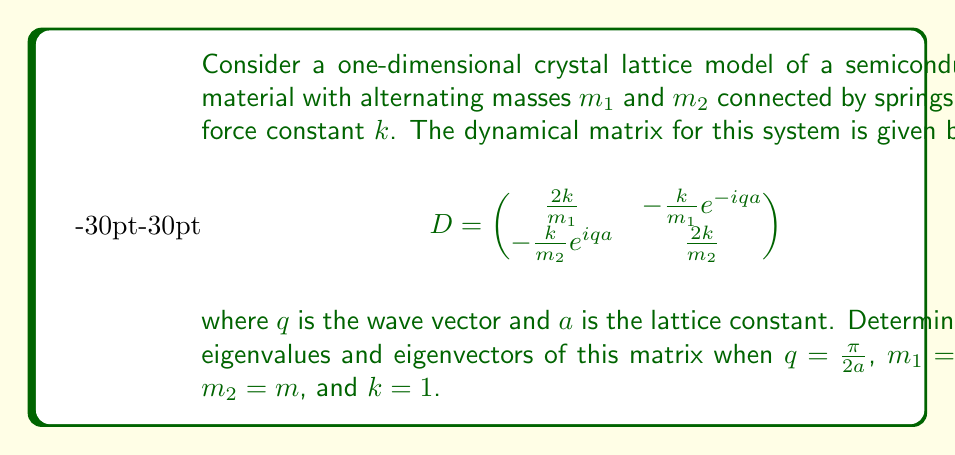Show me your answer to this math problem. To solve this problem, we'll follow these steps:

1) First, let's substitute the given values into the dynamical matrix:
   $q = \frac{\pi}{2a}$, $m_1 = 2m$, $m_2 = m$, and $k = 1$

   $$D = \begin{pmatrix}
   \frac{1}{m} & -\frac{1}{2m}e^{-i\frac{\pi}{2}} \\
   -\frac{1}{m}e^{i\frac{\pi}{2}} & \frac{2}{m}
   \end{pmatrix}$$

2) Simplify using $e^{-i\frac{\pi}{2}} = -i$ and $e^{i\frac{\pi}{2}} = i$:

   $$D = \begin{pmatrix}
   \frac{1}{m} & \frac{i}{2m} \\
   -\frac{i}{m} & \frac{2}{m}
   \end{pmatrix}$$

3) To find the eigenvalues, we solve the characteristic equation:
   $\det(D - \lambda I) = 0$

   $$\begin{vmatrix}
   \frac{1}{m} - \lambda & \frac{i}{2m} \\
   -\frac{i}{m} & \frac{2}{m} - \lambda
   \end{vmatrix} = 0$$

4) Expand the determinant:
   $(\frac{1}{m} - \lambda)(\frac{2}{m} - \lambda) + \frac{1}{2m^2} = 0$

5) Simplify:
   $\lambda^2 - \frac{3}{m}\lambda + \frac{1}{m^2} = 0$

6) Solve this quadratic equation:
   $\lambda = \frac{\frac{3}{m} \pm \sqrt{(\frac{3}{m})^2 - 4(\frac{1}{m^2})}}{2}$
   
   $\lambda = \frac{3 \pm \sqrt{5}}{2m}$

7) To find the eigenvectors, we solve $(D - \lambda I)\vec{v} = 0$ for each eigenvalue:

   For $\lambda_1 = \frac{3 + \sqrt{5}}{2m}$:
   $$\begin{pmatrix}
   \frac{1}{m} - \frac{3 + \sqrt{5}}{2m} & \frac{i}{2m} \\
   -\frac{i}{m} & \frac{2}{m} - \frac{3 + \sqrt{5}}{2m}
   \end{pmatrix}\begin{pmatrix}
   v_1 \\
   v_2
   \end{pmatrix} = \begin{pmatrix}
   0 \\
   0
   \end{pmatrix}$$

   Solving this system gives us:
   $\vec{v_1} = \begin{pmatrix}
   1 \\
   -i(\frac{1 + \sqrt{5}}{2})
   \end{pmatrix}$

   For $\lambda_2 = \frac{3 - \sqrt{5}}{2m}$:
   Following the same process, we get:
   $\vec{v_2} = \begin{pmatrix}
   1 \\
   -i(\frac{1 - \sqrt{5}}{2})
   \end{pmatrix}$
Answer: Eigenvalues: $\lambda_1 = \frac{3 + \sqrt{5}}{2m}$, $\lambda_2 = \frac{3 - \sqrt{5}}{2m}$
Eigenvectors: $\vec{v_1} = (1, -i(\frac{1 + \sqrt{5}}{2}))^T$, $\vec{v_2} = (1, -i(\frac{1 - \sqrt{5}}{2}))^T$ 